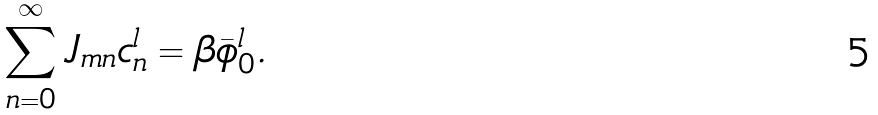<formula> <loc_0><loc_0><loc_500><loc_500>\sum _ { n = 0 } ^ { \infty } J _ { m n } c ^ { l } _ { n } = \beta \bar { \phi } ^ { l } _ { 0 } .</formula> 